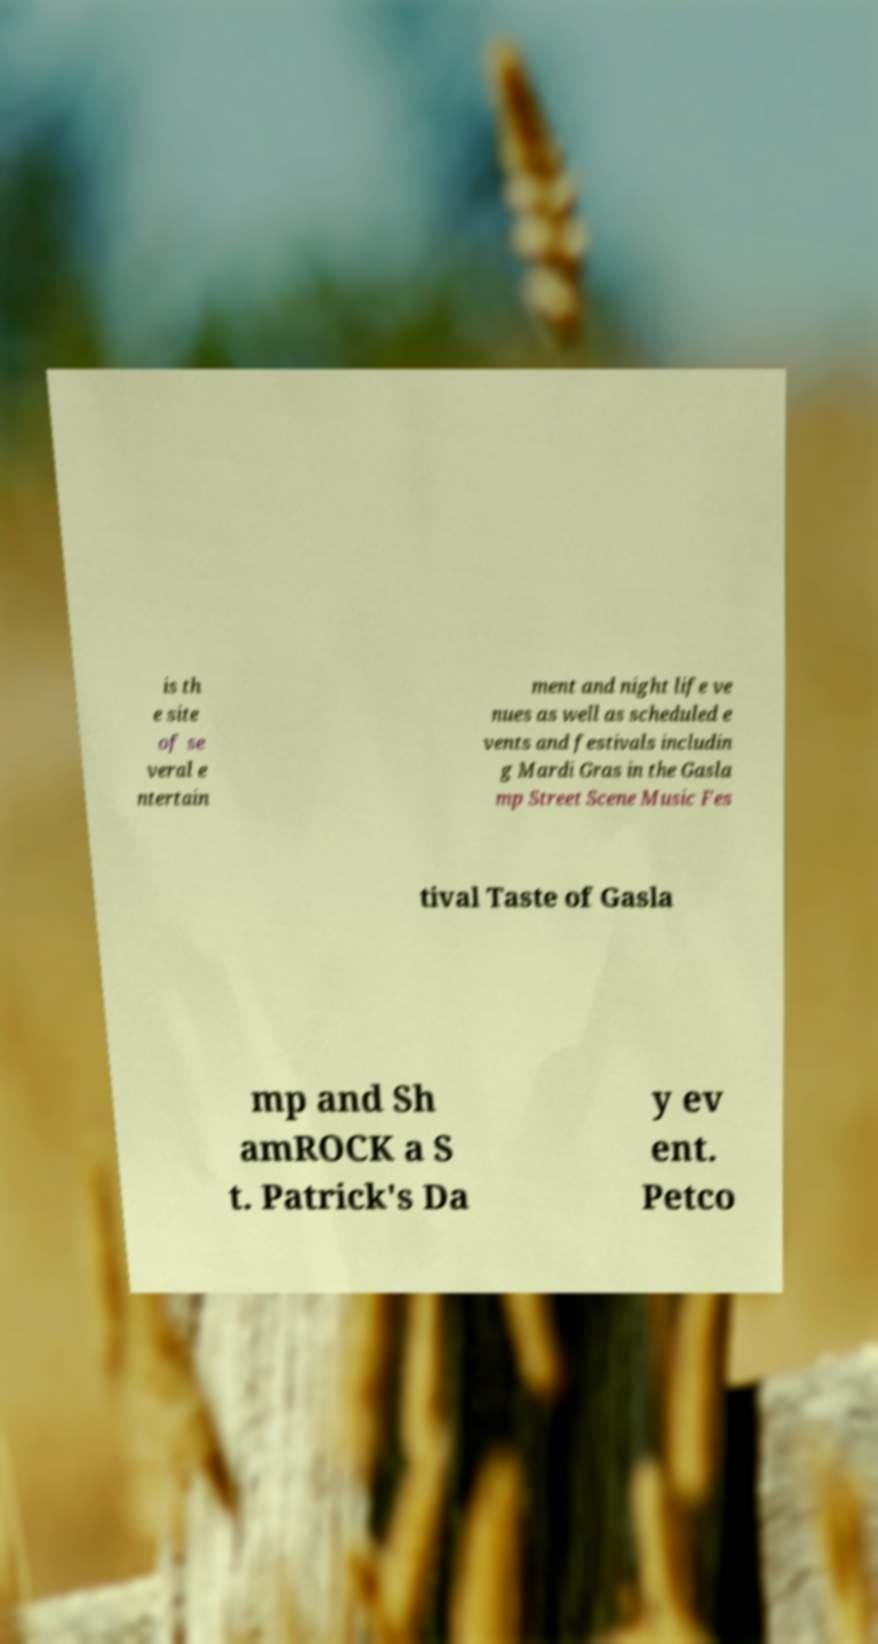Could you assist in decoding the text presented in this image and type it out clearly? is th e site of se veral e ntertain ment and night life ve nues as well as scheduled e vents and festivals includin g Mardi Gras in the Gasla mp Street Scene Music Fes tival Taste of Gasla mp and Sh amROCK a S t. Patrick's Da y ev ent. Petco 